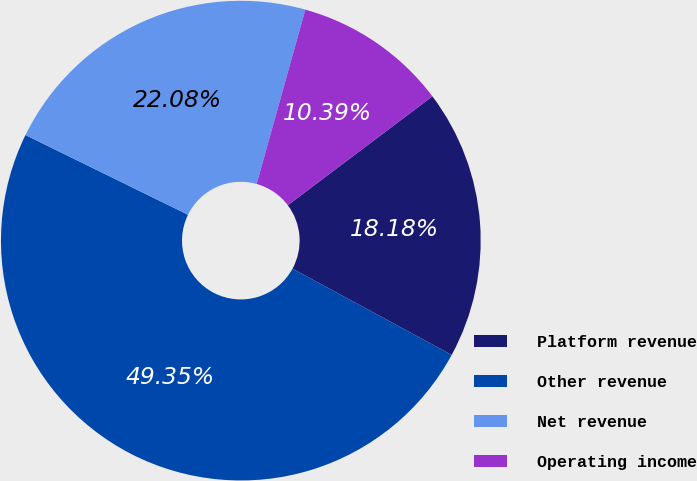Convert chart to OTSL. <chart><loc_0><loc_0><loc_500><loc_500><pie_chart><fcel>Platform revenue<fcel>Other revenue<fcel>Net revenue<fcel>Operating income<nl><fcel>18.18%<fcel>49.35%<fcel>22.08%<fcel>10.39%<nl></chart> 